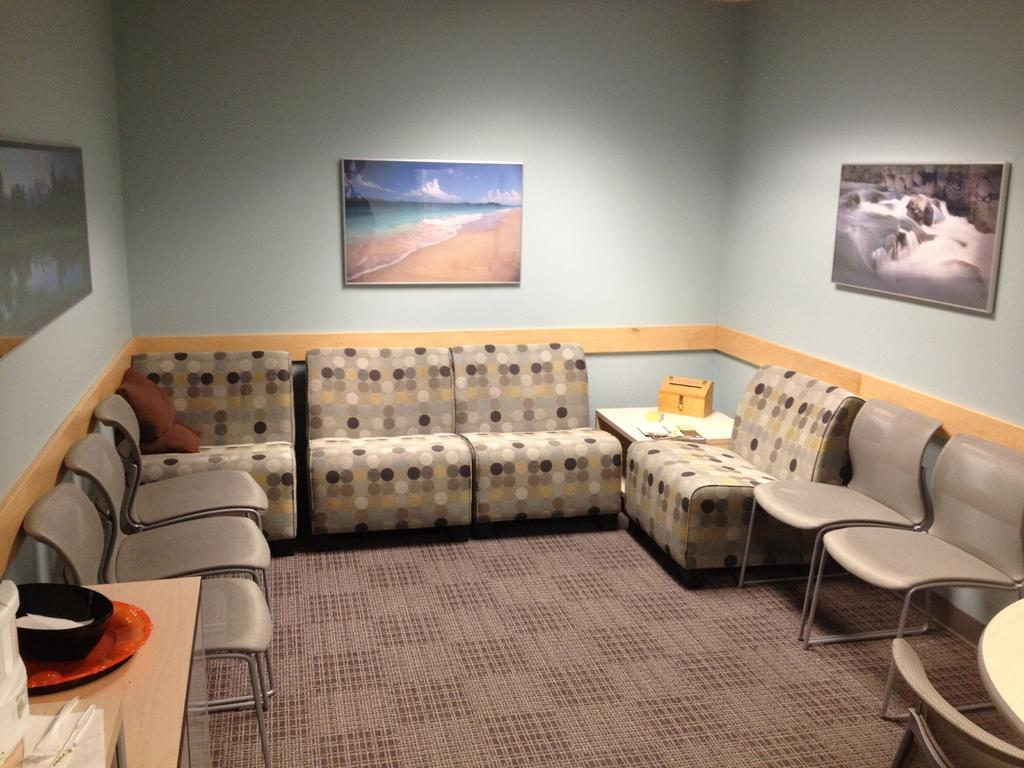What type of furniture is on the floor in the image? There are chairs on the floor in the image. What other piece of furniture can be seen in the image? There is a table in the image. What is on top of the table? There are objects on the table. What can be seen in the background of the image? There is a wall in the background. Is there any decoration on the wall? Yes, there is a photo frame on the wall. What is the current health status of the person in the photo frame? There is no person in the photo frame, and therefore no health status can be determined. 